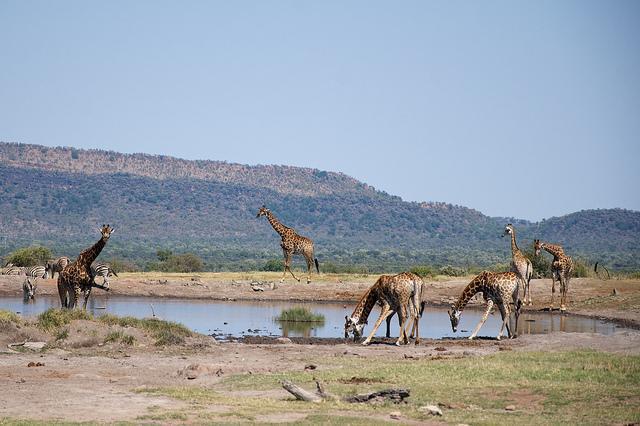How many giraffes are there?
Give a very brief answer. 2. 